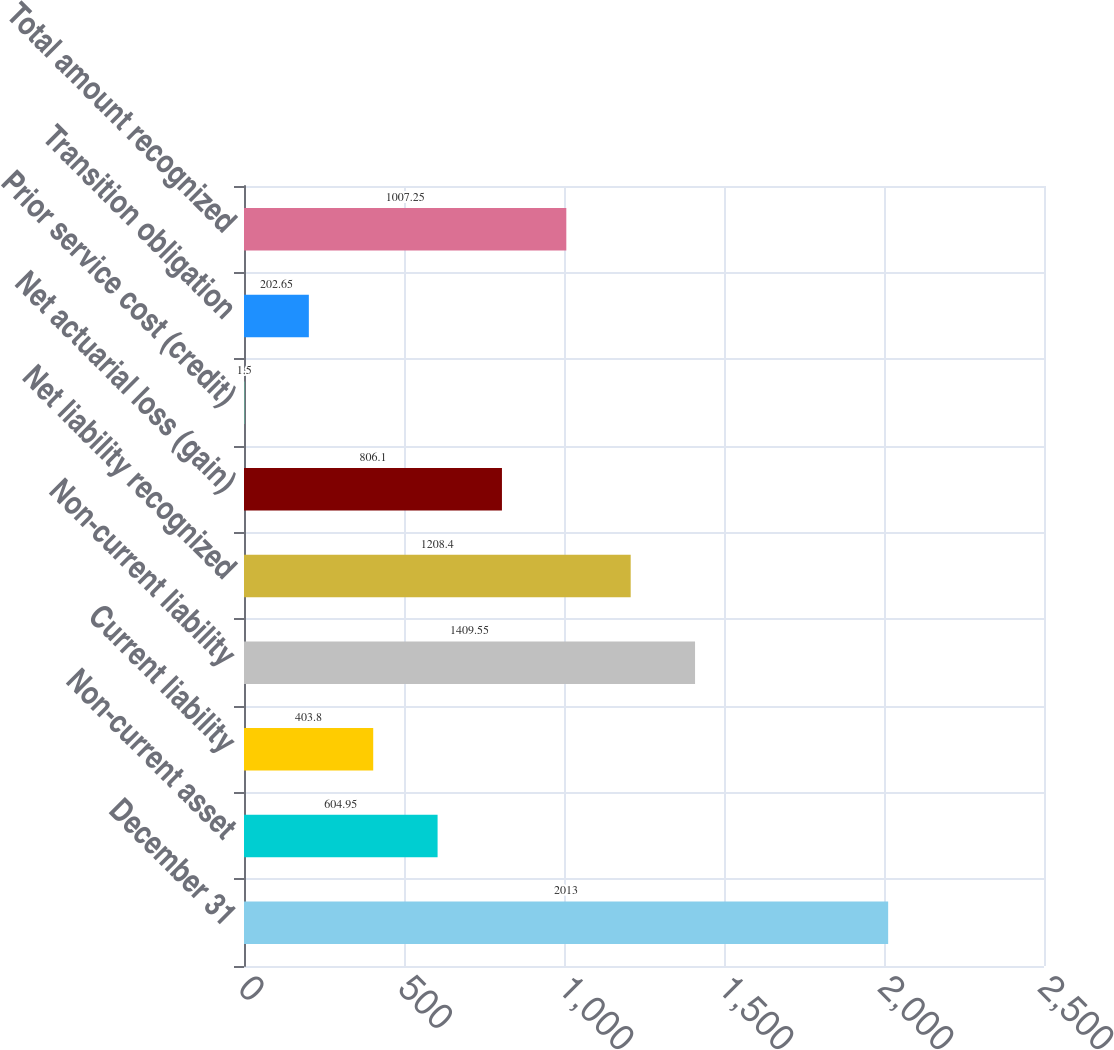<chart> <loc_0><loc_0><loc_500><loc_500><bar_chart><fcel>December 31<fcel>Non-current asset<fcel>Current liability<fcel>Non-current liability<fcel>Net liability recognized<fcel>Net actuarial loss (gain)<fcel>Prior service cost (credit)<fcel>Transition obligation<fcel>Total amount recognized<nl><fcel>2013<fcel>604.95<fcel>403.8<fcel>1409.55<fcel>1208.4<fcel>806.1<fcel>1.5<fcel>202.65<fcel>1007.25<nl></chart> 